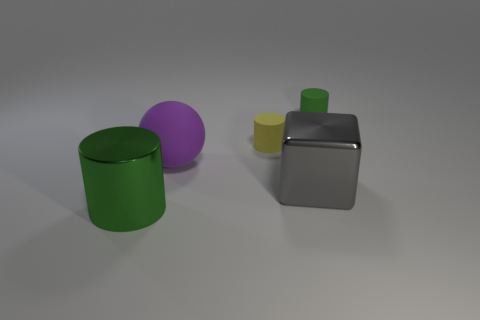What can this assortment of objects tell us about their potential use? These objects appear to be simple geometric shapes commonly used as teaching tools or elements in a visual design software tutorial. They may be utilized to demonstrate concepts such as volume, space, color mixing, shadow casting, and the principles of perspective in a three-dimensional environment. 